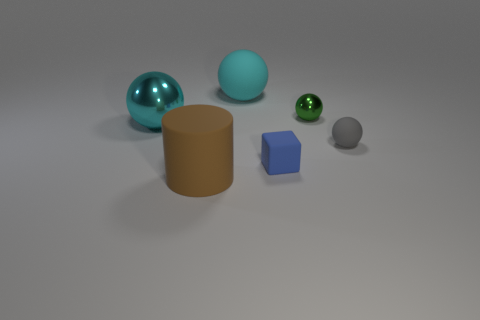Add 1 gray things. How many objects exist? 7 Subtract all green cylinders. How many cyan balls are left? 2 Subtract all gray cylinders. Subtract all large rubber things. How many objects are left? 4 Add 6 tiny green objects. How many tiny green objects are left? 7 Add 3 small gray rubber things. How many small gray rubber things exist? 4 Subtract all cyan balls. How many balls are left? 2 Subtract 1 green spheres. How many objects are left? 5 Subtract all cubes. How many objects are left? 5 Subtract 1 cubes. How many cubes are left? 0 Subtract all cyan cylinders. Subtract all purple blocks. How many cylinders are left? 1 